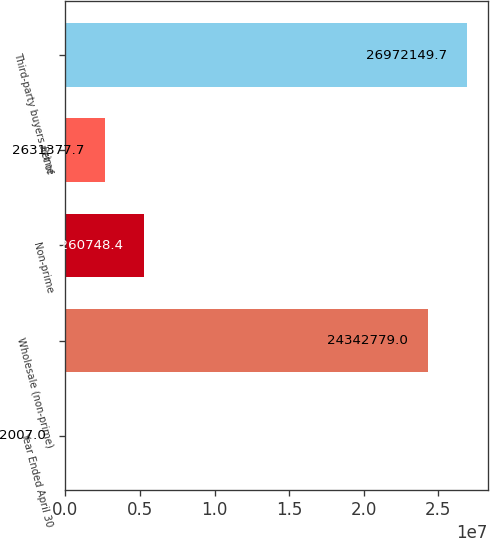Convert chart to OTSL. <chart><loc_0><loc_0><loc_500><loc_500><bar_chart><fcel>Year Ended April 30<fcel>Wholesale (non-prime)<fcel>Non-prime<fcel>Prime<fcel>Third-party buyers net of<nl><fcel>2007<fcel>2.43428e+07<fcel>5.26075e+06<fcel>2.63138e+06<fcel>2.69721e+07<nl></chart> 